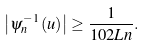<formula> <loc_0><loc_0><loc_500><loc_500>\left | \psi _ { n } ^ { - 1 } \left ( u \right ) \right | \geq \frac { 1 } { 1 0 2 L n } .</formula> 